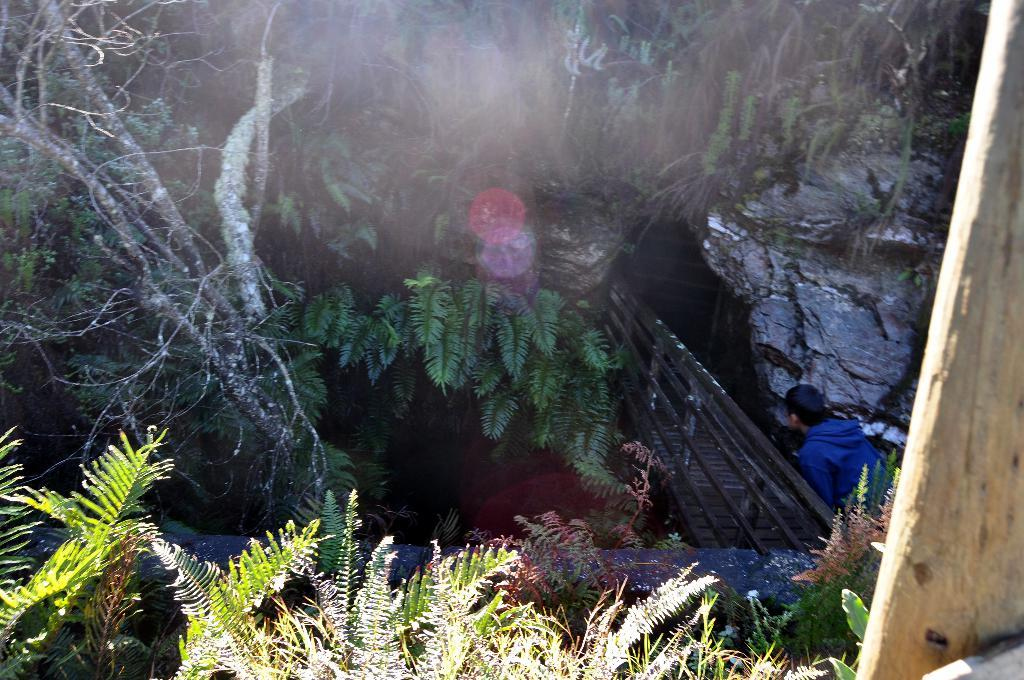What type of natural elements can be seen in the image? There are trees in the image. What man-made structure is present in the image? There is a bridge in the image. Can you describe any other objects in the image? There is a rock in the image. What is the person in the image wearing? A person is wearing a blue dress in the image. How many frogs are sitting on the cake in the image? There is no cake or frogs present in the image. What type of shell is visible on the clam in the image? There is no clam present in the image. 